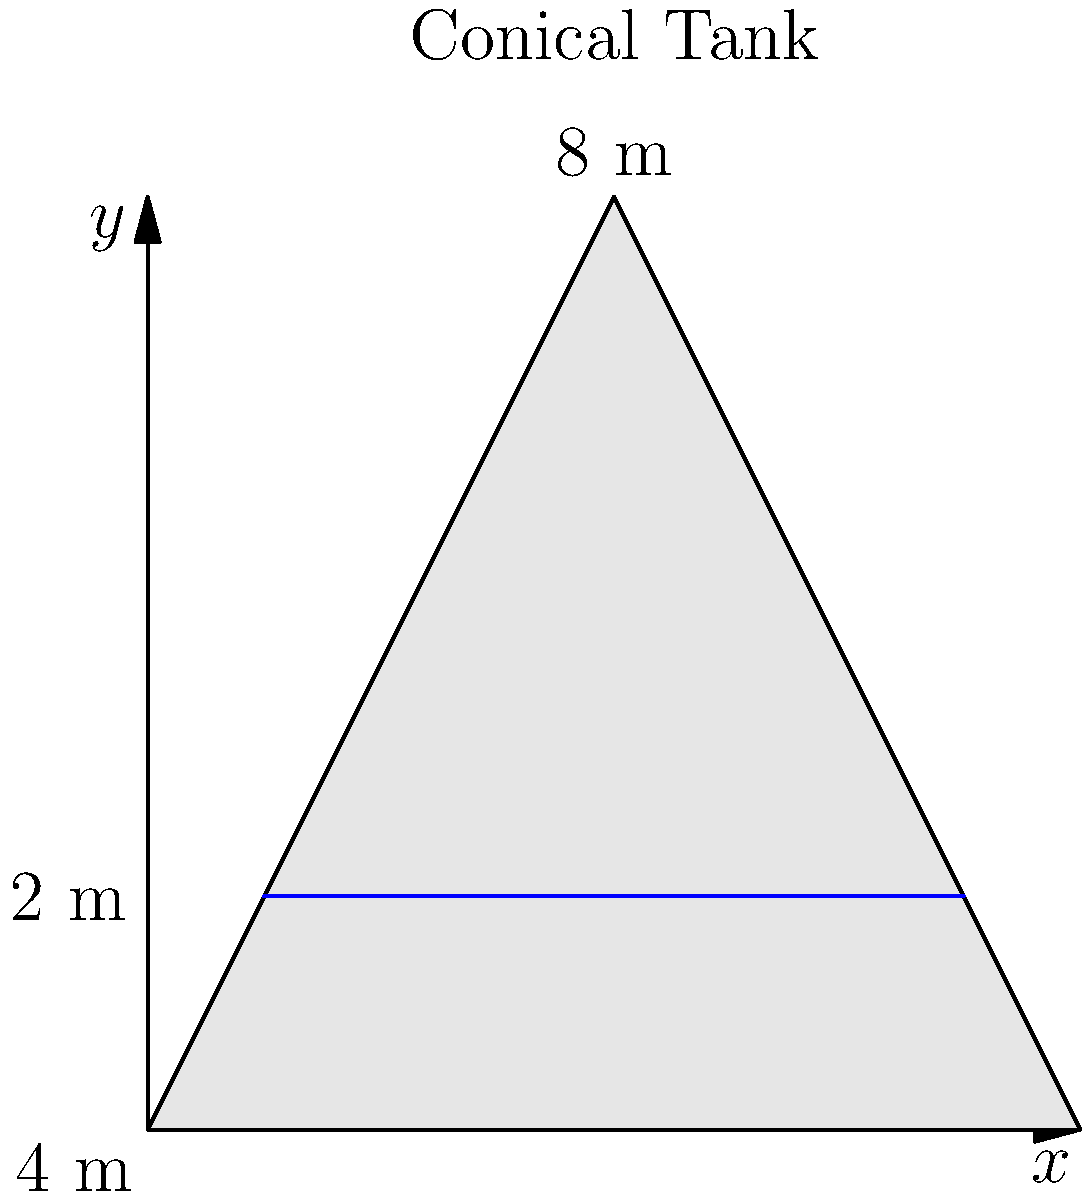A conical water tank has a height of 8 meters and a base radius of 4 meters. The tank is full of water and needs to be emptied. Calculate the work done in pumping the water out of the top of the tank. Assume the density of water is 1000 kg/m³ and the acceleration due to gravity is 9.8 m/s². Express your answer in Joules, rounded to the nearest whole number. To solve this problem, we'll follow these steps:

1) First, we need to set up the integral for the work done. The work is given by:

   $$W = \int_0^8 \rho g h \cdot \pi r^2 \cdot dh$$

   where $\rho$ is the density of water, $g$ is the acceleration due to gravity, $h$ is the height from the bottom of the tank, and $r$ is the radius at height $h$.

2) We need to express $r$ in terms of $h$. From the similar triangles formed, we can write:

   $$\frac{r}{4} = \frac{8-h}{8}$$

   Solving for $r$:

   $$r = 4 - \frac{h}{2}$$

3) Now we can set up our integral:

   $$W = \int_0^8 1000 \cdot 9.8 \cdot h \cdot \pi \left(4 - \frac{h}{2}\right)^2 \cdot dh$$

4) Simplify the integrand:

   $$W = 9800\pi \int_0^8 h \left(16 - 4h + \frac{h^2}{4}\right) \cdot dh$$

   $$W = 9800\pi \int_0^8 \left(16h - 4h^2 + \frac{h^3}{4}\right) \cdot dh$$

5) Integrate:

   $$W = 9800\pi \left[8h^2 - \frac{4h^3}{3} + \frac{h^4}{16}\right]_0^8$$

6) Evaluate the integral:

   $$W = 9800\pi \left[(512 - 682.67 + 256) - (0 - 0 + 0)\right]$$
   $$W = 9800\pi \cdot 85.33$$
   $$W \approx 2,622,533.87 \text{ Joules}$$

7) Rounding to the nearest whole number:

   $$W \approx 2,622,534 \text{ Joules}$$
Answer: 2,622,534 J 